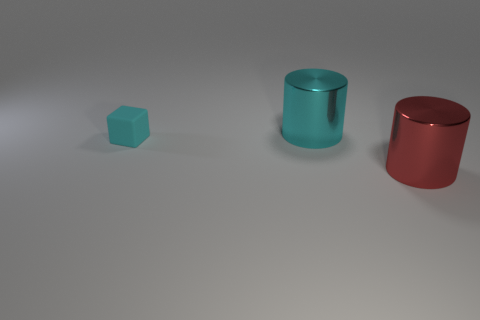Is there anything else that is the same size as the cyan rubber thing?
Ensure brevity in your answer.  No. There is a big shiny thing that is in front of the tiny rubber object; is its shape the same as the object left of the large cyan shiny object?
Ensure brevity in your answer.  No. What number of other things are there of the same material as the red object
Keep it short and to the point. 1. Are there any large red objects behind the thing that is right of the big shiny object behind the tiny matte block?
Your answer should be very brief. No. Does the tiny cyan thing have the same material as the cyan cylinder?
Ensure brevity in your answer.  No. Is there any other thing that is the same shape as the matte object?
Keep it short and to the point. No. What material is the big object in front of the large shiny thing behind the small cyan thing?
Ensure brevity in your answer.  Metal. There is a cylinder that is behind the small cyan object; what is its size?
Give a very brief answer. Large. There is a thing that is both on the right side of the tiny rubber object and in front of the big cyan metal cylinder; what color is it?
Give a very brief answer. Red. Does the metallic cylinder that is in front of the cyan matte block have the same size as the small cube?
Your response must be concise. No. 